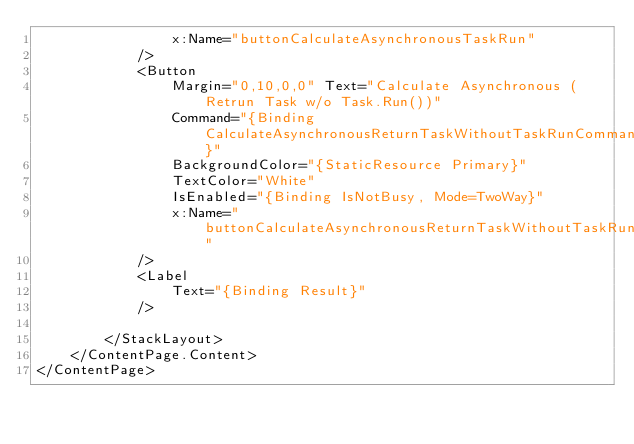<code> <loc_0><loc_0><loc_500><loc_500><_XML_>                x:Name="buttonCalculateAsynchronousTaskRun"
            />
            <Button 
                Margin="0,10,0,0" Text="Calculate Asynchronous (Retrun Task w/o Task.Run())"
                Command="{Binding CalculateAsynchronousReturnTaskWithoutTaskRunCommand}"
                BackgroundColor="{StaticResource Primary}"
                TextColor="White" 
                IsEnabled="{Binding IsNotBusy, Mode=TwoWay}"
                x:Name="buttonCalculateAsynchronousReturnTaskWithoutTaskRun"
            />
            <Label
                Text="{Binding Result}" 
            />

        </StackLayout>
    </ContentPage.Content>
</ContentPage>
</code> 